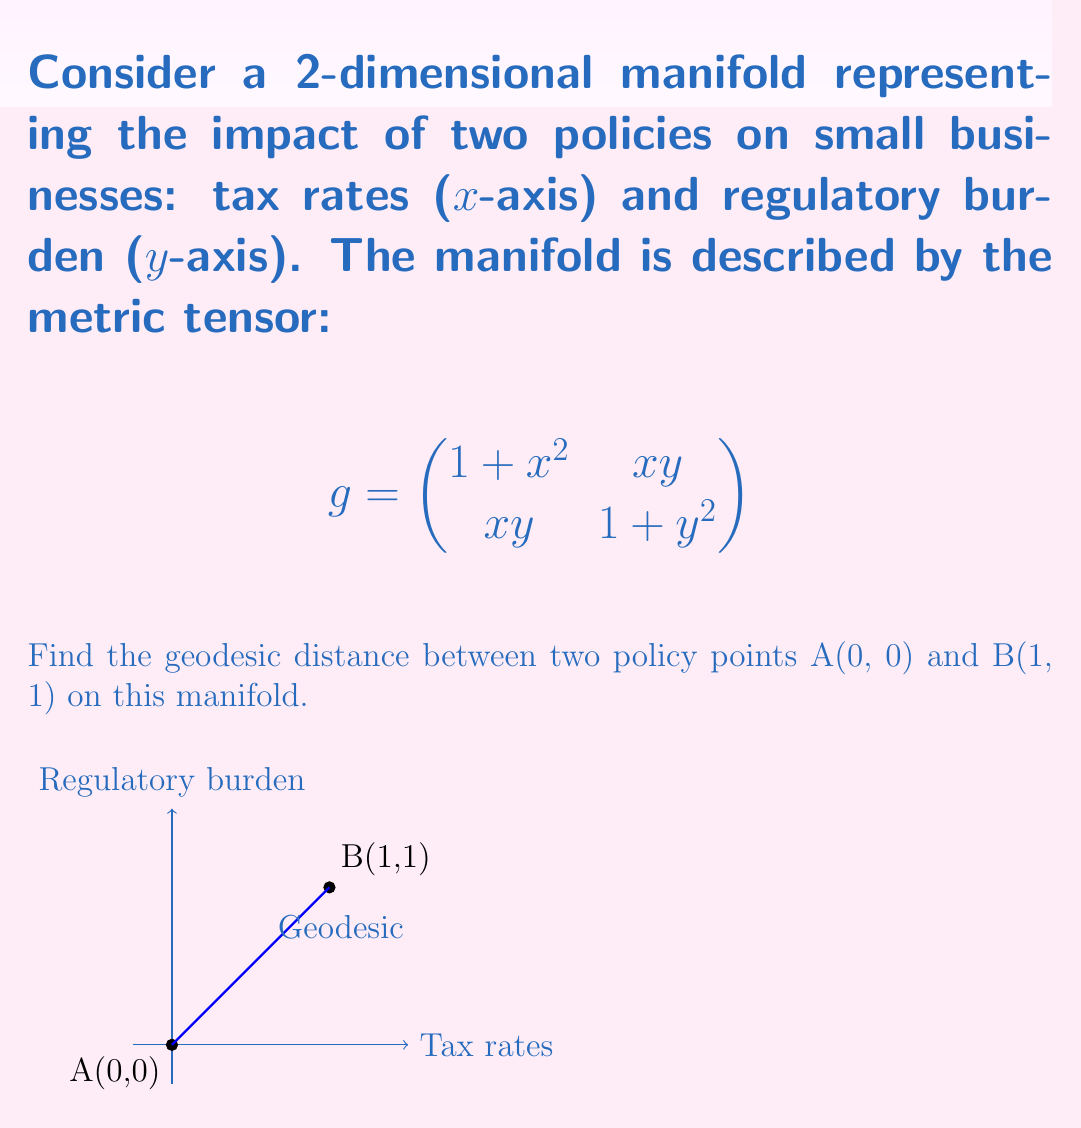Can you answer this question? To find the geodesic distance between two points on a manifold, we need to solve the geodesic equation and then calculate the length of the resulting curve. However, for this complex manifold, an exact solution is challenging. We'll use a numerical approximation method.

1) The arc length of a curve $\gamma(t) = (x(t), y(t))$ on the manifold is given by:

   $$L = \int_0^1 \sqrt{g_{11}\dot{x}^2 + 2g_{12}\dot{x}\dot{y} + g_{22}\dot{y}^2} dt$$

2) We'll assume a linear path between A and B as an initial approximation:
   $x(t) = t$, $y(t) = t$, where $0 \leq t \leq 1$

3) Substituting into the arc length formula:

   $$L = \int_0^1 \sqrt{(1+t^2)(1)^2 + 2t^2(1)(1) + (1+t^2)(1)^2} dt$$

4) Simplifying:

   $$L = \int_0^1 \sqrt{2 + 4t^2} dt$$

5) This integral doesn't have a simple closed form. We can evaluate it numerically:

   $$L \approx 1.7627$$

6) This is an upper bound for the true geodesic distance, as the actual geodesic would be a curve that minimizes this length.

7) For a more accurate result, we would need to solve the geodesic equations numerically or use more advanced approximation techniques.
Answer: $\approx 1.7627$ (upper bound) 